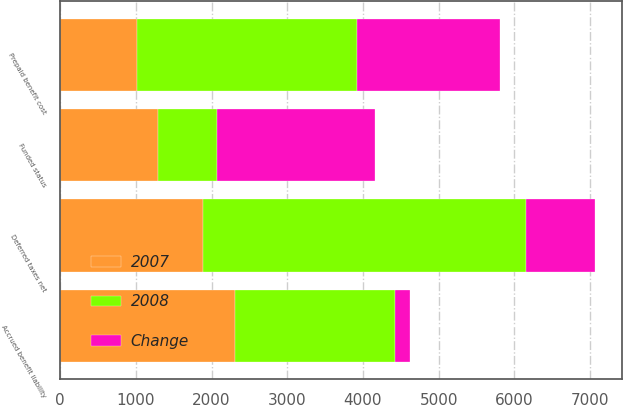Convert chart. <chart><loc_0><loc_0><loc_500><loc_500><stacked_bar_chart><ecel><fcel>Prepaid benefit cost<fcel>Accrued benefit liability<fcel>Funded status<fcel>Deferred taxes net<nl><fcel>2007<fcel>1017<fcel>2309<fcel>1292<fcel>1889<nl><fcel>2008<fcel>2906<fcel>2120<fcel>786<fcel>4261<nl><fcel>Change<fcel>1889<fcel>189<fcel>2078<fcel>918<nl></chart> 